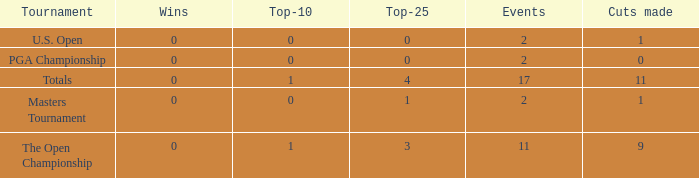How many wins did he have when he played under 2 events? 0.0. 